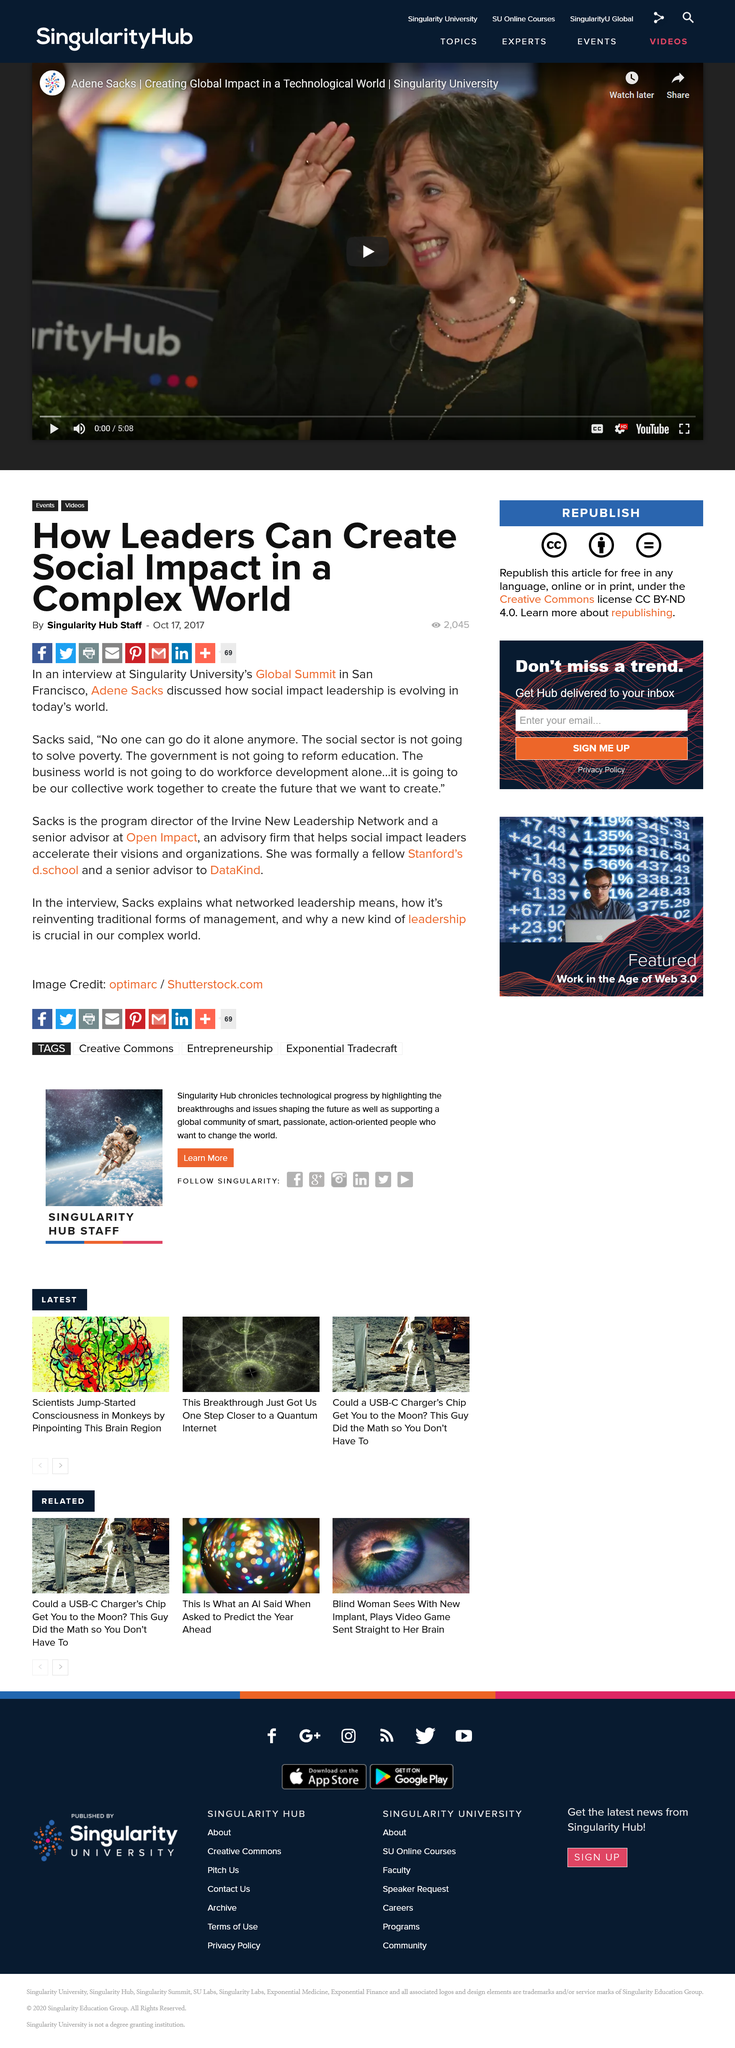Point out several critical features in this image. The social sector and the government's inability to address poverty and reform education is a testament to their overall incompetency in effectively addressing the needs of society. Adene Sacks is the program director of the Irvine New Leadership Network and a Senior Advisor at Open Impact, an advisory firm that supports the ideas and initiatives of social impact leaders and their organizations. Adene Sacks attended the Singularity's Global Summit in San Francisco for an interview. 